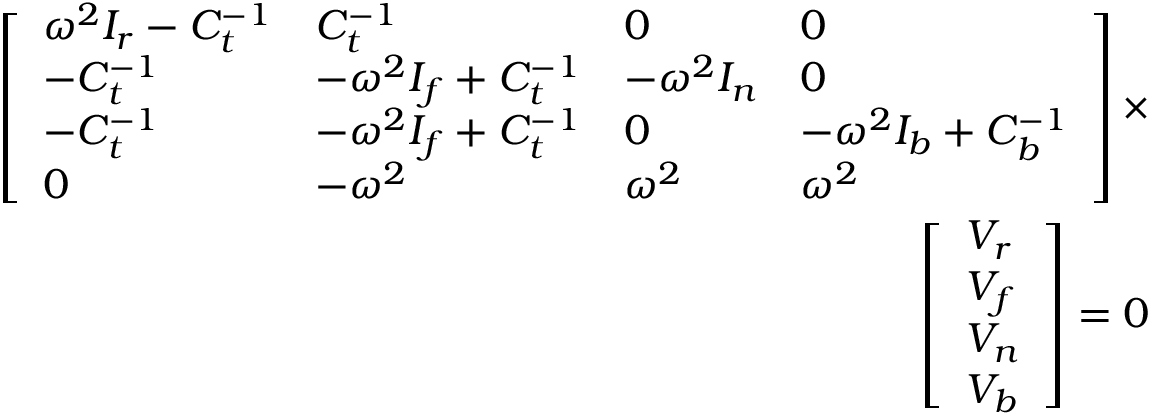Convert formula to latex. <formula><loc_0><loc_0><loc_500><loc_500>\begin{array} { r } { \left [ \begin{array} { l l l l } { \omega ^ { 2 } I _ { r } - C _ { t } ^ { - 1 } } & { C _ { t } ^ { - 1 } } & { 0 } & { 0 } \\ { - C _ { t } ^ { - 1 } } & { - \omega ^ { 2 } I _ { f } + C _ { t } ^ { - 1 } } & { - \omega ^ { 2 } I _ { n } } & { 0 } \\ { - C _ { t } ^ { - 1 } } & { - \omega ^ { 2 } I _ { f } + C _ { t } ^ { - 1 } } & { 0 } & { - \omega ^ { 2 } I _ { b } + C _ { b } ^ { - 1 } } \\ { 0 } & { - \omega ^ { 2 } } & { \omega ^ { 2 } } & { \omega ^ { 2 } } \end{array} \right ] \times } \\ { \left [ \begin{array} { l } { V _ { r } } \\ { V _ { f } } \\ { V _ { n } } \\ { V _ { b } } \end{array} \right ] = 0 } \end{array}</formula> 